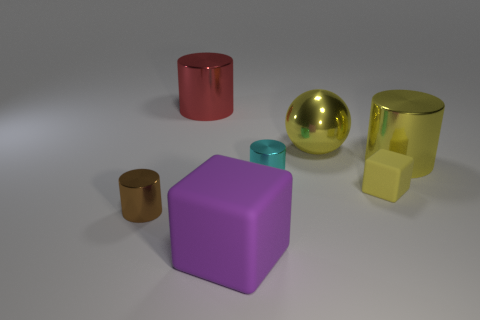Add 2 tiny metal cylinders. How many objects exist? 9 Subtract all cylinders. How many objects are left? 3 Add 4 yellow cylinders. How many yellow cylinders are left? 5 Add 5 brown things. How many brown things exist? 6 Subtract 0 red cubes. How many objects are left? 7 Subtract all small yellow blocks. Subtract all big red things. How many objects are left? 5 